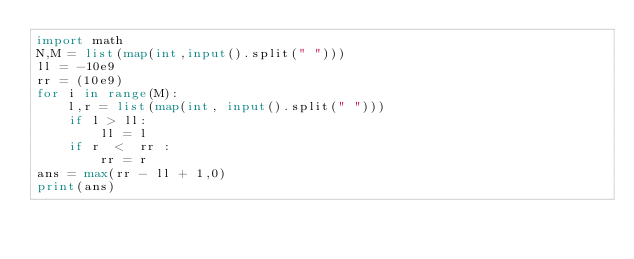Convert code to text. <code><loc_0><loc_0><loc_500><loc_500><_Python_>import math
N,M = list(map(int,input().split(" ")))
ll = -10e9
rr = (10e9)
for i in range(M):
    l,r = list(map(int, input().split(" ")))
    if l > ll:
        ll = l
    if r  <  rr :
        rr = r
ans = max(rr - ll + 1,0)
print(ans)</code> 